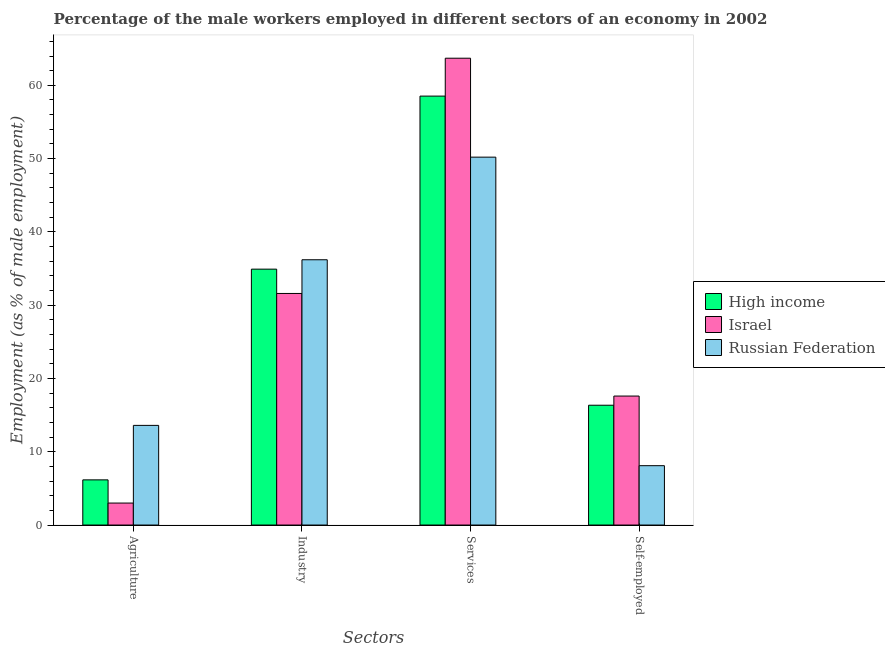How many different coloured bars are there?
Provide a short and direct response. 3. How many groups of bars are there?
Your response must be concise. 4. Are the number of bars per tick equal to the number of legend labels?
Provide a short and direct response. Yes. How many bars are there on the 1st tick from the right?
Make the answer very short. 3. What is the label of the 4th group of bars from the left?
Make the answer very short. Self-employed. What is the percentage of male workers in services in Russian Federation?
Give a very brief answer. 50.2. Across all countries, what is the maximum percentage of male workers in agriculture?
Offer a terse response. 13.6. Across all countries, what is the minimum percentage of male workers in services?
Offer a very short reply. 50.2. In which country was the percentage of male workers in agriculture maximum?
Make the answer very short. Russian Federation. In which country was the percentage of male workers in industry minimum?
Your response must be concise. Israel. What is the total percentage of self employed male workers in the graph?
Make the answer very short. 42.05. What is the difference between the percentage of self employed male workers in Russian Federation and that in High income?
Make the answer very short. -8.25. What is the difference between the percentage of male workers in agriculture in Israel and the percentage of male workers in industry in Russian Federation?
Give a very brief answer. -33.2. What is the average percentage of male workers in industry per country?
Your answer should be very brief. 34.24. What is the difference between the percentage of male workers in agriculture and percentage of male workers in industry in High income?
Your answer should be compact. -28.75. What is the ratio of the percentage of male workers in agriculture in High income to that in Russian Federation?
Provide a succinct answer. 0.45. What is the difference between the highest and the second highest percentage of male workers in agriculture?
Your answer should be compact. 7.43. What is the difference between the highest and the lowest percentage of male workers in agriculture?
Provide a succinct answer. 10.6. In how many countries, is the percentage of male workers in services greater than the average percentage of male workers in services taken over all countries?
Ensure brevity in your answer.  2. Is the sum of the percentage of self employed male workers in High income and Israel greater than the maximum percentage of male workers in agriculture across all countries?
Your response must be concise. Yes. What does the 1st bar from the right in Self-employed represents?
Keep it short and to the point. Russian Federation. How many bars are there?
Provide a succinct answer. 12. How many countries are there in the graph?
Your answer should be compact. 3. What is the difference between two consecutive major ticks on the Y-axis?
Give a very brief answer. 10. Does the graph contain any zero values?
Keep it short and to the point. No. Does the graph contain grids?
Ensure brevity in your answer.  No. Where does the legend appear in the graph?
Offer a very short reply. Center right. How many legend labels are there?
Provide a succinct answer. 3. What is the title of the graph?
Give a very brief answer. Percentage of the male workers employed in different sectors of an economy in 2002. Does "Chad" appear as one of the legend labels in the graph?
Your response must be concise. No. What is the label or title of the X-axis?
Offer a very short reply. Sectors. What is the label or title of the Y-axis?
Make the answer very short. Employment (as % of male employment). What is the Employment (as % of male employment) in High income in Agriculture?
Your response must be concise. 6.17. What is the Employment (as % of male employment) in Russian Federation in Agriculture?
Your answer should be very brief. 13.6. What is the Employment (as % of male employment) in High income in Industry?
Your answer should be compact. 34.92. What is the Employment (as % of male employment) of Israel in Industry?
Provide a succinct answer. 31.6. What is the Employment (as % of male employment) of Russian Federation in Industry?
Offer a terse response. 36.2. What is the Employment (as % of male employment) in High income in Services?
Make the answer very short. 58.53. What is the Employment (as % of male employment) in Israel in Services?
Give a very brief answer. 63.7. What is the Employment (as % of male employment) in Russian Federation in Services?
Offer a terse response. 50.2. What is the Employment (as % of male employment) of High income in Self-employed?
Make the answer very short. 16.35. What is the Employment (as % of male employment) of Israel in Self-employed?
Provide a succinct answer. 17.6. What is the Employment (as % of male employment) of Russian Federation in Self-employed?
Your response must be concise. 8.1. Across all Sectors, what is the maximum Employment (as % of male employment) of High income?
Ensure brevity in your answer.  58.53. Across all Sectors, what is the maximum Employment (as % of male employment) of Israel?
Make the answer very short. 63.7. Across all Sectors, what is the maximum Employment (as % of male employment) of Russian Federation?
Provide a short and direct response. 50.2. Across all Sectors, what is the minimum Employment (as % of male employment) in High income?
Your answer should be compact. 6.17. Across all Sectors, what is the minimum Employment (as % of male employment) of Russian Federation?
Offer a very short reply. 8.1. What is the total Employment (as % of male employment) in High income in the graph?
Ensure brevity in your answer.  115.96. What is the total Employment (as % of male employment) in Israel in the graph?
Make the answer very short. 115.9. What is the total Employment (as % of male employment) of Russian Federation in the graph?
Make the answer very short. 108.1. What is the difference between the Employment (as % of male employment) of High income in Agriculture and that in Industry?
Your response must be concise. -28.75. What is the difference between the Employment (as % of male employment) in Israel in Agriculture and that in Industry?
Offer a terse response. -28.6. What is the difference between the Employment (as % of male employment) in Russian Federation in Agriculture and that in Industry?
Your answer should be compact. -22.6. What is the difference between the Employment (as % of male employment) of High income in Agriculture and that in Services?
Your response must be concise. -52.37. What is the difference between the Employment (as % of male employment) of Israel in Agriculture and that in Services?
Offer a very short reply. -60.7. What is the difference between the Employment (as % of male employment) of Russian Federation in Agriculture and that in Services?
Your response must be concise. -36.6. What is the difference between the Employment (as % of male employment) of High income in Agriculture and that in Self-employed?
Provide a succinct answer. -10.18. What is the difference between the Employment (as % of male employment) of Israel in Agriculture and that in Self-employed?
Your answer should be compact. -14.6. What is the difference between the Employment (as % of male employment) in High income in Industry and that in Services?
Ensure brevity in your answer.  -23.61. What is the difference between the Employment (as % of male employment) in Israel in Industry and that in Services?
Give a very brief answer. -32.1. What is the difference between the Employment (as % of male employment) in High income in Industry and that in Self-employed?
Your answer should be compact. 18.57. What is the difference between the Employment (as % of male employment) in Russian Federation in Industry and that in Self-employed?
Ensure brevity in your answer.  28.1. What is the difference between the Employment (as % of male employment) in High income in Services and that in Self-employed?
Your answer should be compact. 42.18. What is the difference between the Employment (as % of male employment) of Israel in Services and that in Self-employed?
Offer a very short reply. 46.1. What is the difference between the Employment (as % of male employment) in Russian Federation in Services and that in Self-employed?
Your answer should be compact. 42.1. What is the difference between the Employment (as % of male employment) in High income in Agriculture and the Employment (as % of male employment) in Israel in Industry?
Offer a terse response. -25.43. What is the difference between the Employment (as % of male employment) of High income in Agriculture and the Employment (as % of male employment) of Russian Federation in Industry?
Provide a short and direct response. -30.03. What is the difference between the Employment (as % of male employment) of Israel in Agriculture and the Employment (as % of male employment) of Russian Federation in Industry?
Provide a short and direct response. -33.2. What is the difference between the Employment (as % of male employment) of High income in Agriculture and the Employment (as % of male employment) of Israel in Services?
Provide a short and direct response. -57.53. What is the difference between the Employment (as % of male employment) of High income in Agriculture and the Employment (as % of male employment) of Russian Federation in Services?
Provide a succinct answer. -44.03. What is the difference between the Employment (as % of male employment) of Israel in Agriculture and the Employment (as % of male employment) of Russian Federation in Services?
Keep it short and to the point. -47.2. What is the difference between the Employment (as % of male employment) in High income in Agriculture and the Employment (as % of male employment) in Israel in Self-employed?
Your answer should be compact. -11.43. What is the difference between the Employment (as % of male employment) of High income in Agriculture and the Employment (as % of male employment) of Russian Federation in Self-employed?
Offer a terse response. -1.93. What is the difference between the Employment (as % of male employment) in Israel in Agriculture and the Employment (as % of male employment) in Russian Federation in Self-employed?
Give a very brief answer. -5.1. What is the difference between the Employment (as % of male employment) in High income in Industry and the Employment (as % of male employment) in Israel in Services?
Give a very brief answer. -28.78. What is the difference between the Employment (as % of male employment) of High income in Industry and the Employment (as % of male employment) of Russian Federation in Services?
Your answer should be compact. -15.28. What is the difference between the Employment (as % of male employment) in Israel in Industry and the Employment (as % of male employment) in Russian Federation in Services?
Provide a short and direct response. -18.6. What is the difference between the Employment (as % of male employment) of High income in Industry and the Employment (as % of male employment) of Israel in Self-employed?
Provide a succinct answer. 17.32. What is the difference between the Employment (as % of male employment) of High income in Industry and the Employment (as % of male employment) of Russian Federation in Self-employed?
Ensure brevity in your answer.  26.82. What is the difference between the Employment (as % of male employment) in High income in Services and the Employment (as % of male employment) in Israel in Self-employed?
Your response must be concise. 40.93. What is the difference between the Employment (as % of male employment) in High income in Services and the Employment (as % of male employment) in Russian Federation in Self-employed?
Offer a terse response. 50.43. What is the difference between the Employment (as % of male employment) of Israel in Services and the Employment (as % of male employment) of Russian Federation in Self-employed?
Provide a short and direct response. 55.6. What is the average Employment (as % of male employment) of High income per Sectors?
Make the answer very short. 28.99. What is the average Employment (as % of male employment) in Israel per Sectors?
Your response must be concise. 28.98. What is the average Employment (as % of male employment) in Russian Federation per Sectors?
Your response must be concise. 27.02. What is the difference between the Employment (as % of male employment) in High income and Employment (as % of male employment) in Israel in Agriculture?
Provide a succinct answer. 3.17. What is the difference between the Employment (as % of male employment) of High income and Employment (as % of male employment) of Russian Federation in Agriculture?
Provide a short and direct response. -7.43. What is the difference between the Employment (as % of male employment) of Israel and Employment (as % of male employment) of Russian Federation in Agriculture?
Keep it short and to the point. -10.6. What is the difference between the Employment (as % of male employment) in High income and Employment (as % of male employment) in Israel in Industry?
Offer a terse response. 3.32. What is the difference between the Employment (as % of male employment) of High income and Employment (as % of male employment) of Russian Federation in Industry?
Offer a very short reply. -1.28. What is the difference between the Employment (as % of male employment) in High income and Employment (as % of male employment) in Israel in Services?
Keep it short and to the point. -5.17. What is the difference between the Employment (as % of male employment) of High income and Employment (as % of male employment) of Russian Federation in Services?
Provide a succinct answer. 8.33. What is the difference between the Employment (as % of male employment) in Israel and Employment (as % of male employment) in Russian Federation in Services?
Keep it short and to the point. 13.5. What is the difference between the Employment (as % of male employment) in High income and Employment (as % of male employment) in Israel in Self-employed?
Ensure brevity in your answer.  -1.25. What is the difference between the Employment (as % of male employment) of High income and Employment (as % of male employment) of Russian Federation in Self-employed?
Make the answer very short. 8.25. What is the ratio of the Employment (as % of male employment) in High income in Agriculture to that in Industry?
Make the answer very short. 0.18. What is the ratio of the Employment (as % of male employment) of Israel in Agriculture to that in Industry?
Your answer should be compact. 0.09. What is the ratio of the Employment (as % of male employment) of Russian Federation in Agriculture to that in Industry?
Your answer should be very brief. 0.38. What is the ratio of the Employment (as % of male employment) of High income in Agriculture to that in Services?
Provide a short and direct response. 0.11. What is the ratio of the Employment (as % of male employment) of Israel in Agriculture to that in Services?
Keep it short and to the point. 0.05. What is the ratio of the Employment (as % of male employment) of Russian Federation in Agriculture to that in Services?
Offer a terse response. 0.27. What is the ratio of the Employment (as % of male employment) in High income in Agriculture to that in Self-employed?
Offer a very short reply. 0.38. What is the ratio of the Employment (as % of male employment) in Israel in Agriculture to that in Self-employed?
Your answer should be compact. 0.17. What is the ratio of the Employment (as % of male employment) of Russian Federation in Agriculture to that in Self-employed?
Give a very brief answer. 1.68. What is the ratio of the Employment (as % of male employment) of High income in Industry to that in Services?
Make the answer very short. 0.6. What is the ratio of the Employment (as % of male employment) in Israel in Industry to that in Services?
Keep it short and to the point. 0.5. What is the ratio of the Employment (as % of male employment) in Russian Federation in Industry to that in Services?
Provide a short and direct response. 0.72. What is the ratio of the Employment (as % of male employment) of High income in Industry to that in Self-employed?
Your answer should be compact. 2.14. What is the ratio of the Employment (as % of male employment) of Israel in Industry to that in Self-employed?
Keep it short and to the point. 1.8. What is the ratio of the Employment (as % of male employment) in Russian Federation in Industry to that in Self-employed?
Your answer should be very brief. 4.47. What is the ratio of the Employment (as % of male employment) of High income in Services to that in Self-employed?
Provide a succinct answer. 3.58. What is the ratio of the Employment (as % of male employment) of Israel in Services to that in Self-employed?
Ensure brevity in your answer.  3.62. What is the ratio of the Employment (as % of male employment) in Russian Federation in Services to that in Self-employed?
Provide a succinct answer. 6.2. What is the difference between the highest and the second highest Employment (as % of male employment) in High income?
Your answer should be compact. 23.61. What is the difference between the highest and the second highest Employment (as % of male employment) of Israel?
Provide a short and direct response. 32.1. What is the difference between the highest and the lowest Employment (as % of male employment) of High income?
Your response must be concise. 52.37. What is the difference between the highest and the lowest Employment (as % of male employment) in Israel?
Provide a short and direct response. 60.7. What is the difference between the highest and the lowest Employment (as % of male employment) of Russian Federation?
Offer a terse response. 42.1. 